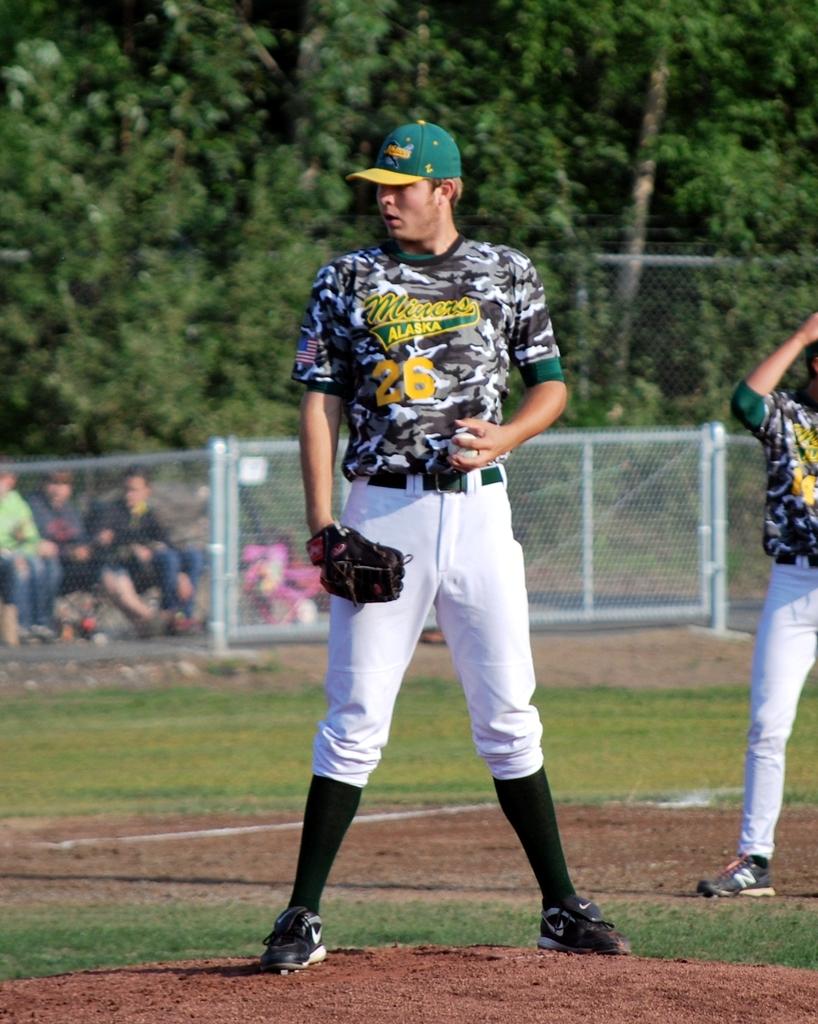What state is this player from?
Provide a succinct answer. Alaska. What is his number?
Make the answer very short. 26. 